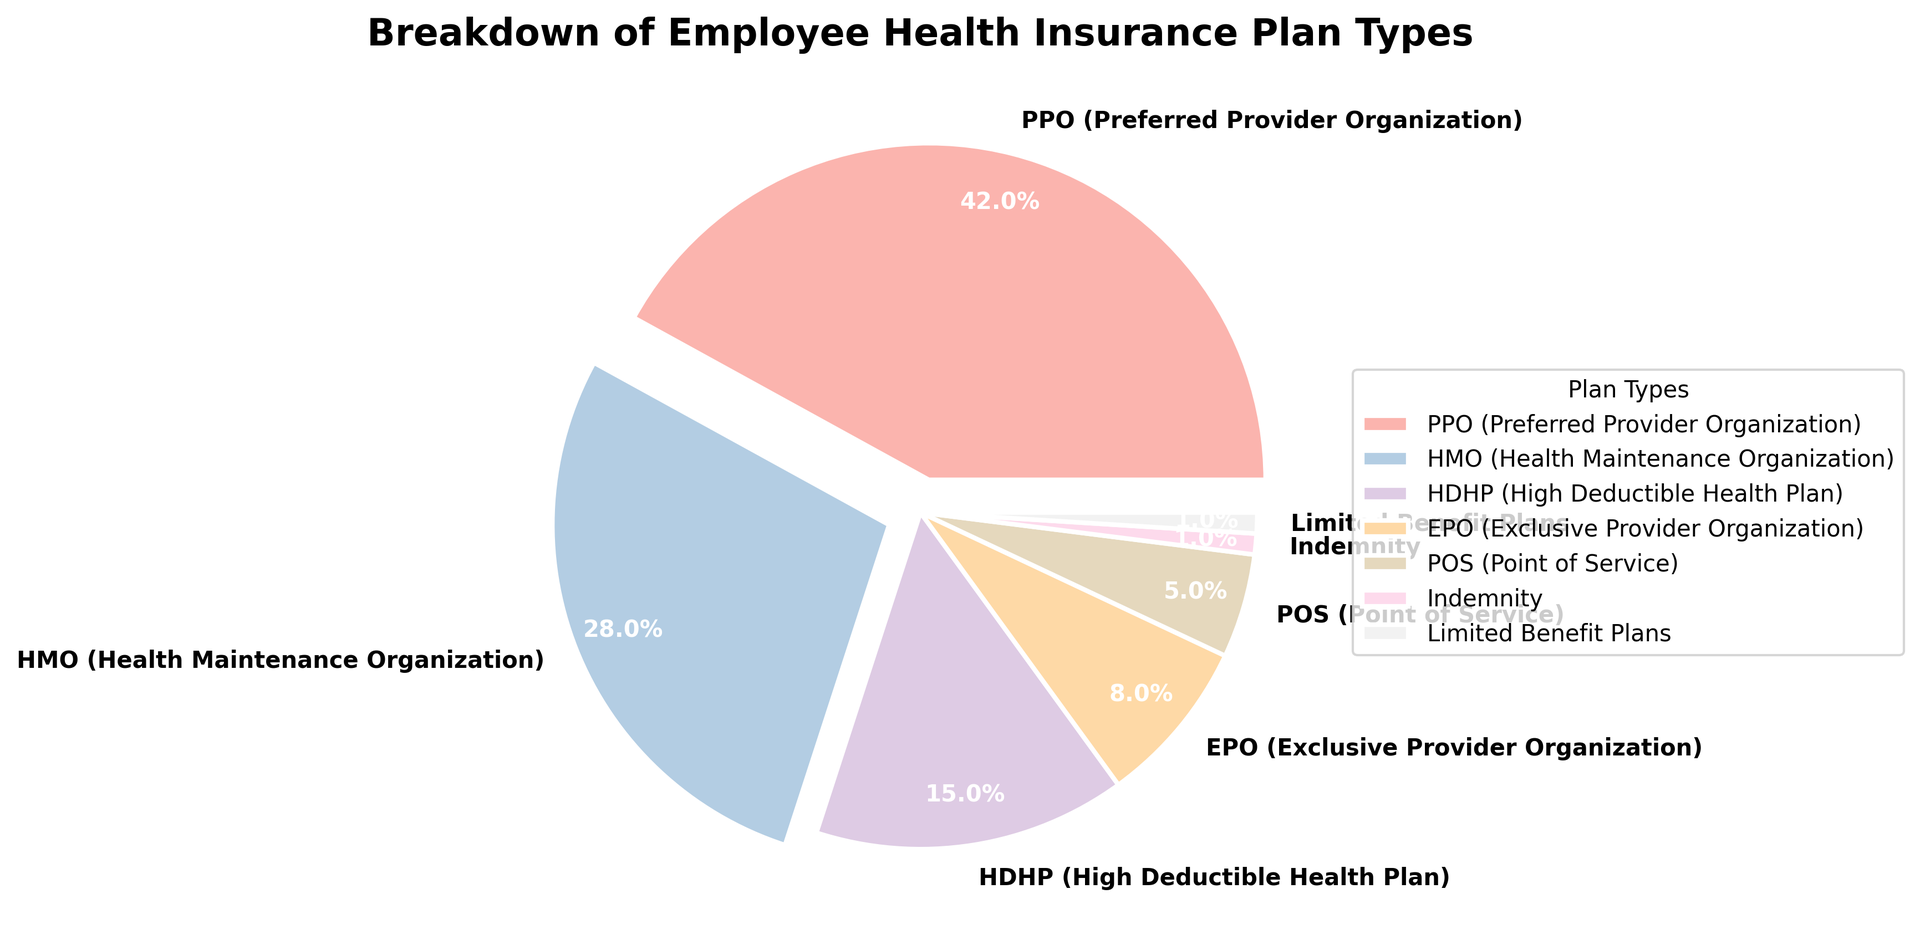What percentage of employees are covered by PPO plans? The chart shows the different types of health insurance plans along with their respective percentages. The segment labeled "PPO" represents 42% of the total.
Answer: 42% Which plan type has the smallest percentage of coverage? The chart includes various segments with the respective percentages labeled. "Indemnity" and "Limited Benefit Plans" both have the smallest percentage at 1% each.
Answer: Indemnity and Limited Benefit Plans What is the total percentage of employees covered by HMO and HDHP plans combined? To find the combined coverage for HMO and HDHP plans, add the percentages for each. HMO is 28% and HDHP is 15%, so 28% + 15% = 43%.
Answer: 43% Which plan type has more coverage, EPO or POS? The chart indicates that EPO has 8% coverage while POS has 5% coverage. Comparing the two values, EPO has a higher coverage percentage.
Answer: EPO Is the percentage of employees covered by PPO plans greater than the combined percentage of HDHP and EPO plans? PPO coverage is 42%. HDHP coverage is 15% and EPO coverage is 8%, making their combined coverage 15% + 8% = 23%. Since 42% is greater than 23%, PPO coverage is indeed greater.
Answer: Yes What is the difference in coverage percentage between PPO and HMO plans? To find the difference, subtract the percentage of HMO from PPO. PPO is 42%, and HMO is 28%, so 42% - 28% = 14%.
Answer: 14% What color represents the POS plan on the chart? Looking at the wedges in the pie chart, each segment is color-coded. The POS segment, with 5% coverage, can be identified by its color in the legend.
Answer: Specific corresponding color in the chart (varies; typically pastel colors can be described if visible) Which plan types add up to 50% coverage together? Reviewing the segments, start combining until reaching close to 50%. HMO (28%) + HDHP (15%) + POS (5%) together sum to 28% + 15% + 5% = 48%, which is closest to 50%.
Answer: HMO, HDHP, and POS Is the total coverage of limited benefit plans and indemnity plans greater than that of POS plans alone? Limited Benefit Plans and Indemnity each have 1% coverage. Combined, it's 1% + 1% = 2%. Since POS has 5%, 2% (combined) is less than 5%.
Answer: No 